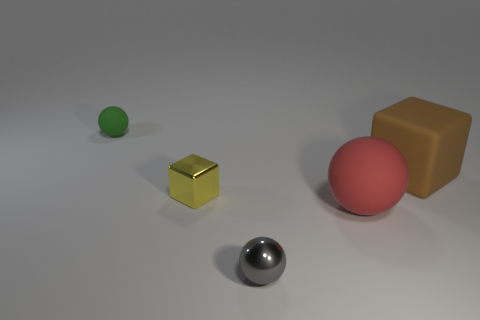Add 1 red things. How many objects exist? 6 Subtract all blocks. How many objects are left? 3 Add 3 small gray objects. How many small gray objects are left? 4 Add 1 large cylinders. How many large cylinders exist? 1 Subtract 0 yellow cylinders. How many objects are left? 5 Subtract all big yellow blocks. Subtract all small green rubber things. How many objects are left? 4 